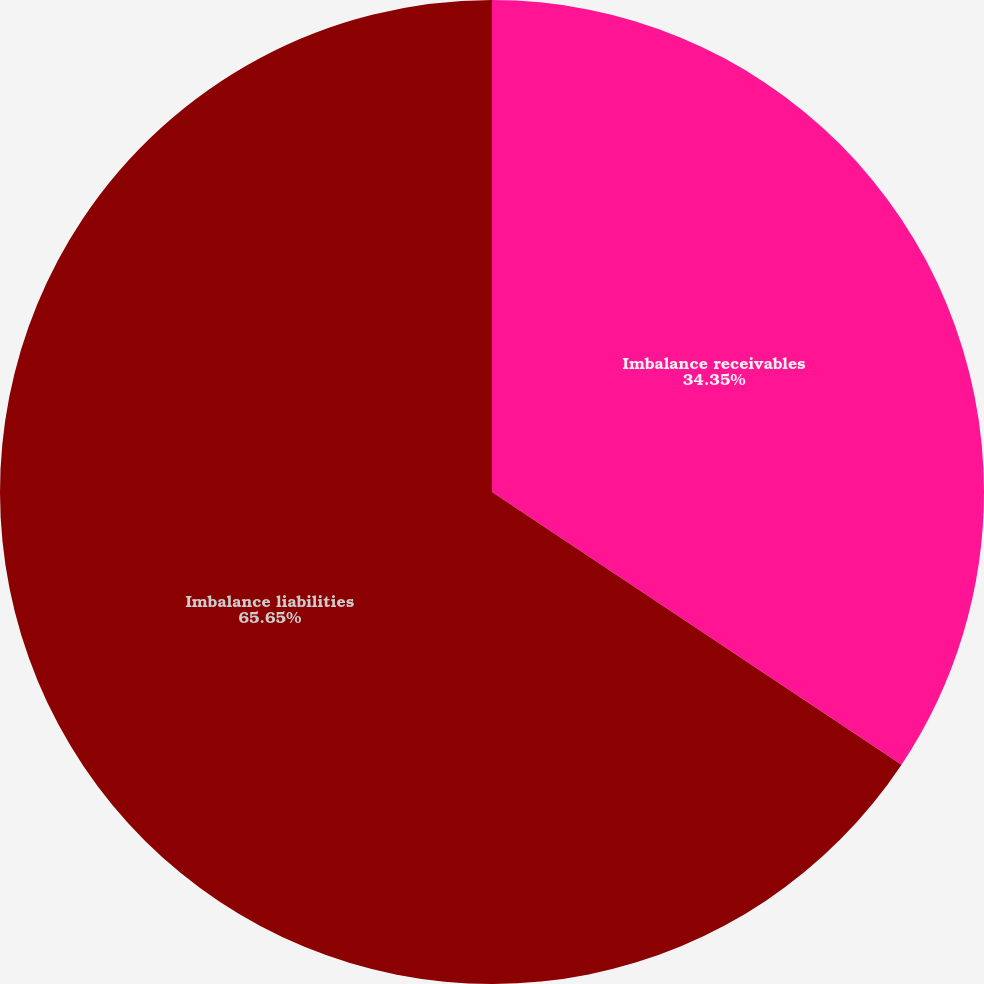<chart> <loc_0><loc_0><loc_500><loc_500><pie_chart><fcel>Imbalance receivables<fcel>Imbalance liabilities<nl><fcel>34.35%<fcel>65.65%<nl></chart> 